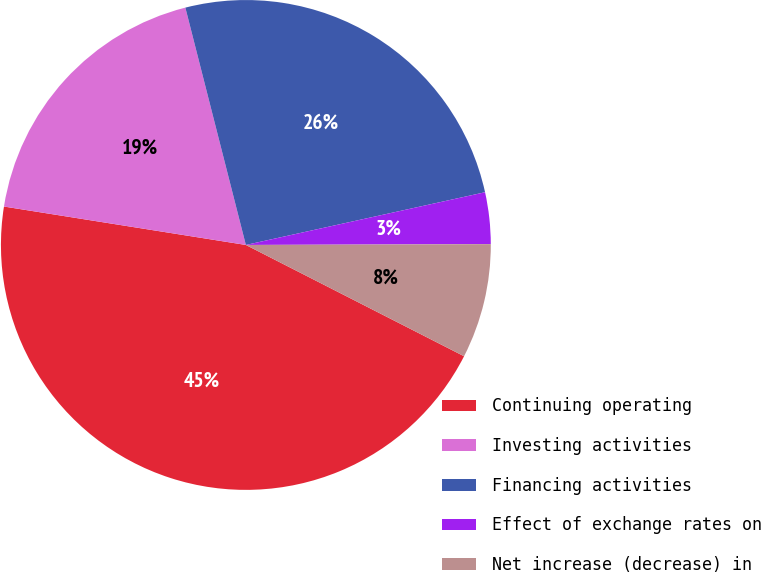Convert chart. <chart><loc_0><loc_0><loc_500><loc_500><pie_chart><fcel>Continuing operating<fcel>Investing activities<fcel>Financing activities<fcel>Effect of exchange rates on<fcel>Net increase (decrease) in<nl><fcel>45.0%<fcel>18.52%<fcel>25.52%<fcel>3.4%<fcel>7.56%<nl></chart> 